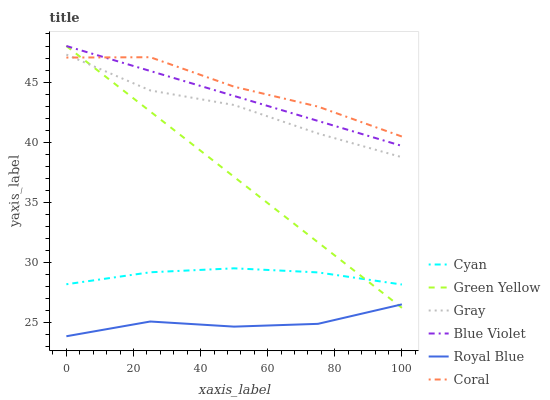Does Royal Blue have the minimum area under the curve?
Answer yes or no. Yes. Does Coral have the maximum area under the curve?
Answer yes or no. Yes. Does Coral have the minimum area under the curve?
Answer yes or no. No. Does Royal Blue have the maximum area under the curve?
Answer yes or no. No. Is Green Yellow the smoothest?
Answer yes or no. Yes. Is Coral the roughest?
Answer yes or no. Yes. Is Royal Blue the smoothest?
Answer yes or no. No. Is Royal Blue the roughest?
Answer yes or no. No. Does Royal Blue have the lowest value?
Answer yes or no. Yes. Does Coral have the lowest value?
Answer yes or no. No. Does Blue Violet have the highest value?
Answer yes or no. Yes. Does Coral have the highest value?
Answer yes or no. No. Is Royal Blue less than Blue Violet?
Answer yes or no. Yes. Is Gray greater than Royal Blue?
Answer yes or no. Yes. Does Gray intersect Coral?
Answer yes or no. Yes. Is Gray less than Coral?
Answer yes or no. No. Is Gray greater than Coral?
Answer yes or no. No. Does Royal Blue intersect Blue Violet?
Answer yes or no. No. 